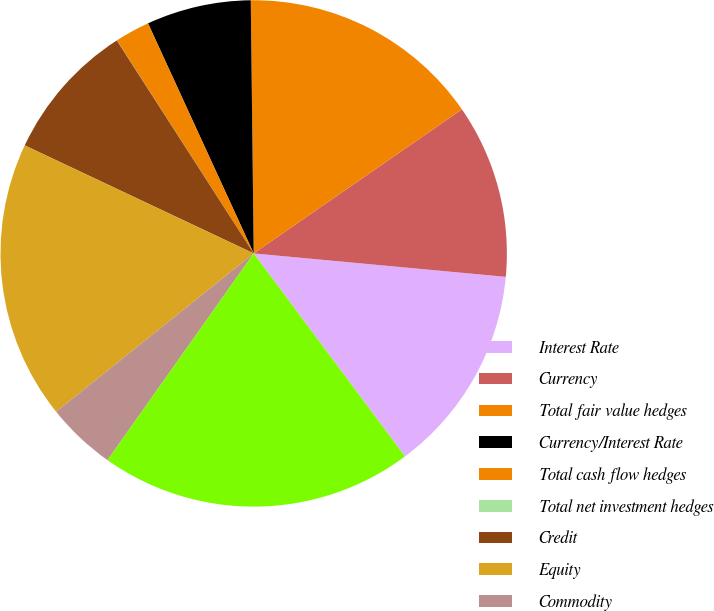Convert chart to OTSL. <chart><loc_0><loc_0><loc_500><loc_500><pie_chart><fcel>Interest Rate<fcel>Currency<fcel>Total fair value hedges<fcel>Currency/Interest Rate<fcel>Total cash flow hedges<fcel>Total net investment hedges<fcel>Credit<fcel>Equity<fcel>Commodity<fcel>Embedded Derivatives<nl><fcel>13.33%<fcel>11.11%<fcel>15.55%<fcel>6.67%<fcel>2.23%<fcel>0.01%<fcel>8.89%<fcel>17.77%<fcel>4.45%<fcel>19.99%<nl></chart> 